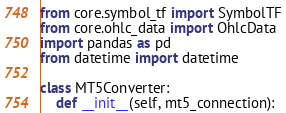Convert code to text. <code><loc_0><loc_0><loc_500><loc_500><_Python_>from core.symbol_tf import SymbolTF
from core.ohlc_data import OhlcData
import pandas as pd
from datetime import datetime

class MT5Converter:
    def __init__(self, mt5_connection):</code> 